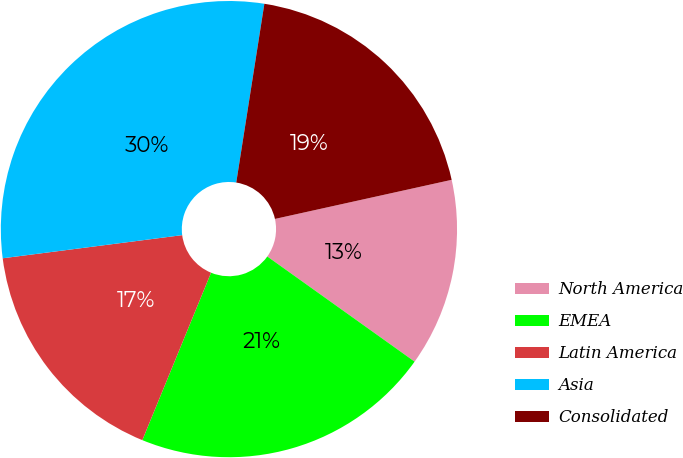Convert chart. <chart><loc_0><loc_0><loc_500><loc_500><pie_chart><fcel>North America<fcel>EMEA<fcel>Latin America<fcel>Asia<fcel>Consolidated<nl><fcel>13.33%<fcel>21.33%<fcel>16.76%<fcel>29.52%<fcel>19.05%<nl></chart> 